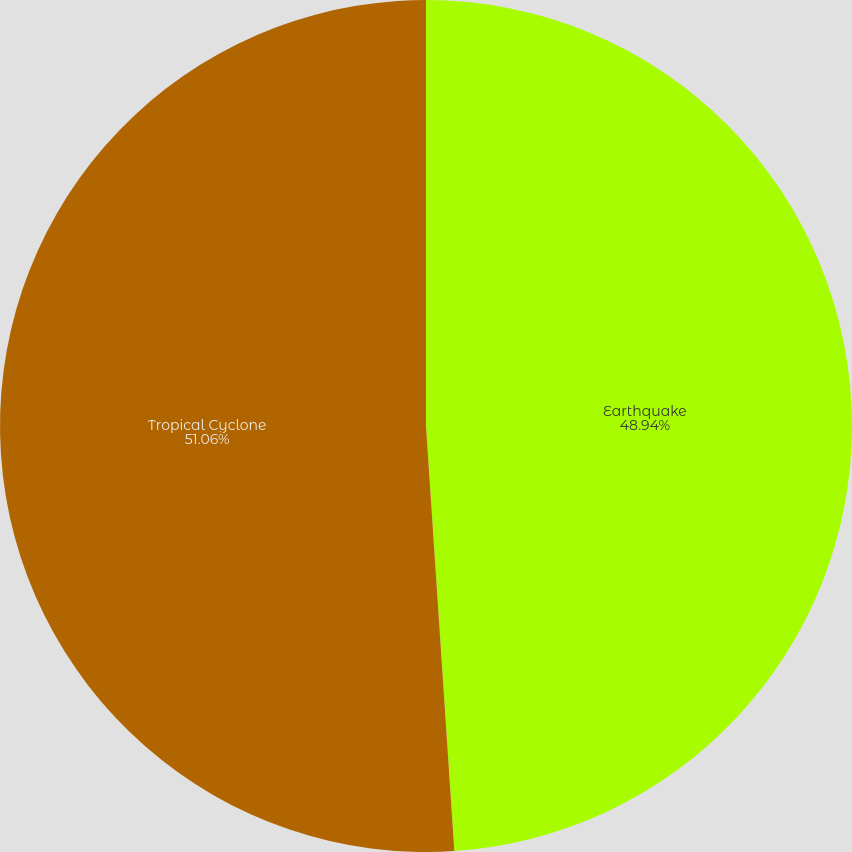Convert chart. <chart><loc_0><loc_0><loc_500><loc_500><pie_chart><fcel>Earthquake<fcel>Tropical Cyclone<nl><fcel>48.94%<fcel>51.06%<nl></chart> 